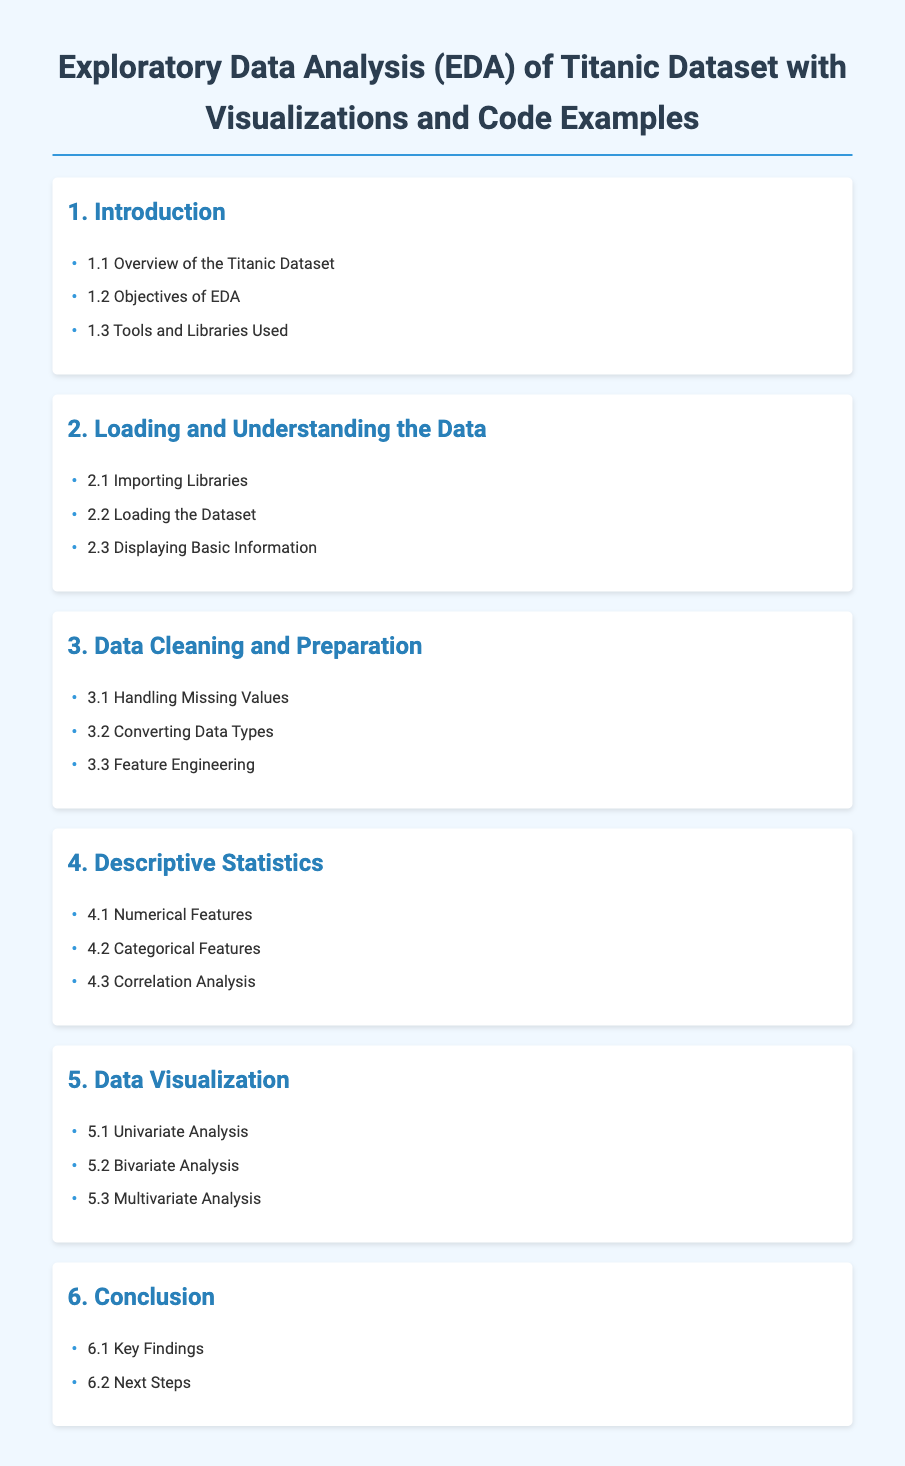What is the title of the document? The title is the main heading of the document, stating its content.
Answer: Exploratory Data Analysis (EDA) of Titanic Dataset with Visualizations and Code Examples What is the first section of the document? The first section provides an introduction to the topic, including an overview, objectives, and tools used.
Answer: Introduction How many subsections are listed under "Data Cleaning and Preparation"? This refers to the total number of specific topics covered in that section.
Answer: 3 What does the "5.2" reference in the document signify? The numeric reference indicates the order and hierarchy of the subsection within Data Visualization.
Answer: Bivariate Analysis What is the background color of the document? The background color of the document is specified in the style section for readability.
Answer: Light blue What section includes Correlation Analysis? The naming of the section provides the direct context for where this analysis is discussed.
Answer: Descriptive Statistics Which library is likely referenced in the "Importing Libraries" subsection? This subsection typically covers libraries necessary for analysis, common in data science.
Answer: Pandas What is the last subsection listed in the document? The last subsection signifies the final key information or conclusion presented in the document.
Answer: Next Steps 